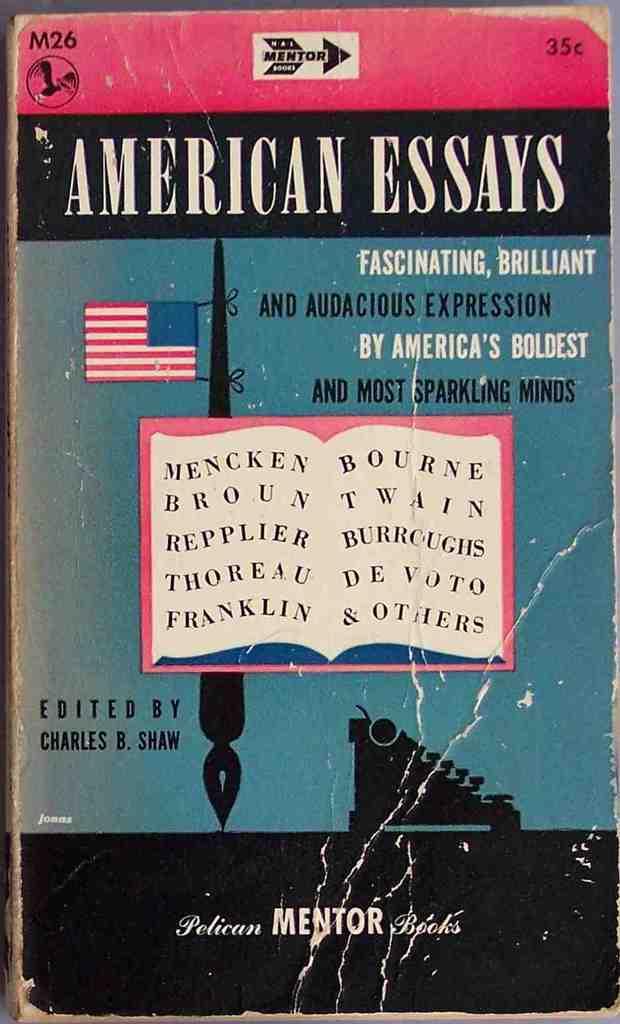Who is the editor?
Make the answer very short. Charles b. shaw. 